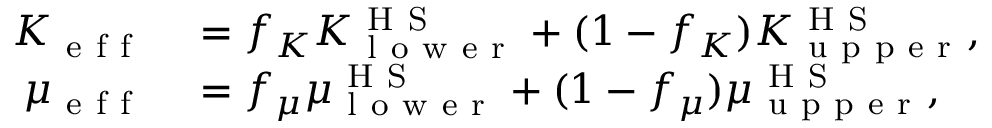<formula> <loc_0><loc_0><loc_500><loc_500>\begin{array} { r l } { K _ { e f f } } & = f _ { K } K _ { l o w e r } ^ { H S } + ( 1 - f _ { K } ) K _ { u p p e r } ^ { H S } , } \\ { \mu _ { e f f } } & = f _ { \mu } \mu _ { l o w e r } ^ { H S } + ( 1 - f _ { \mu } ) \mu _ { u p p e r } ^ { H S } , } \end{array}</formula> 